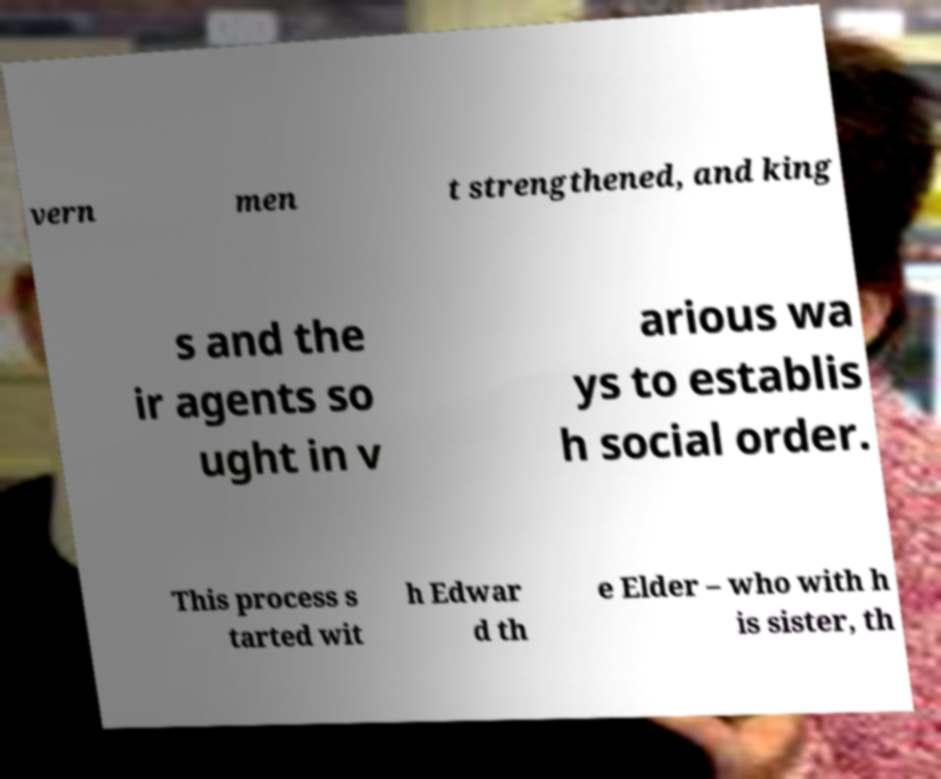Can you read and provide the text displayed in the image?This photo seems to have some interesting text. Can you extract and type it out for me? vern men t strengthened, and king s and the ir agents so ught in v arious wa ys to establis h social order. This process s tarted wit h Edwar d th e Elder – who with h is sister, th 